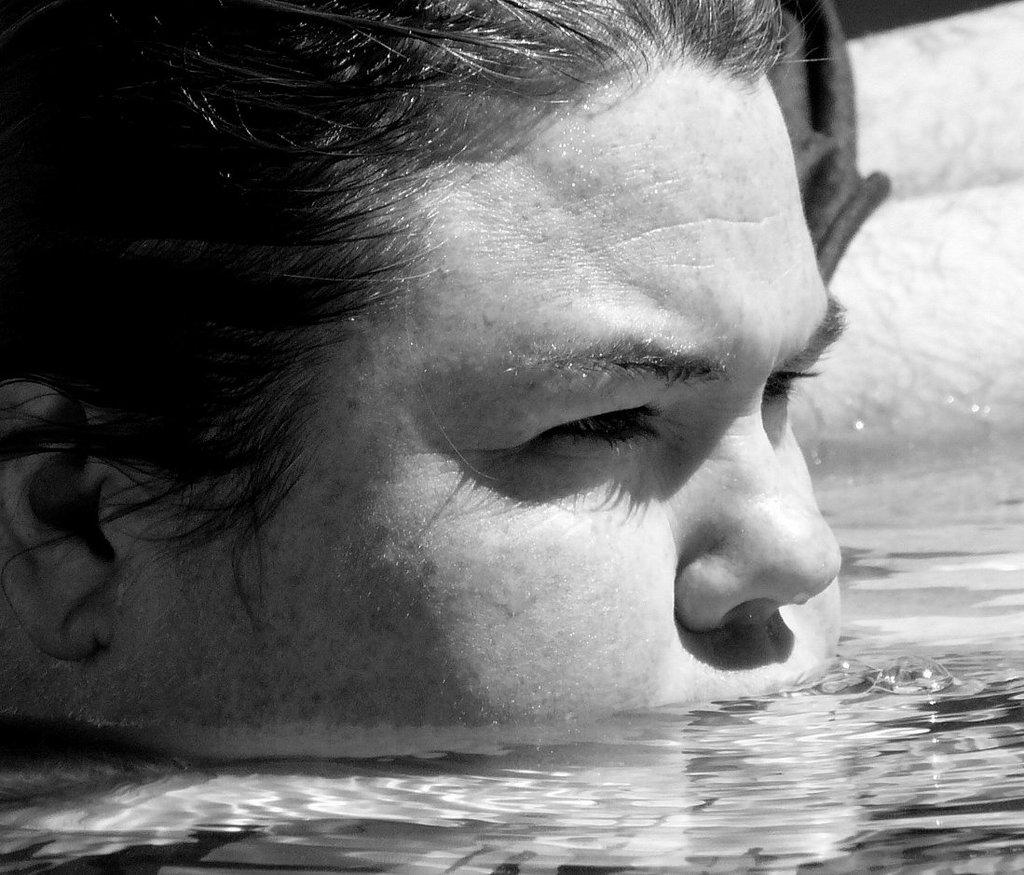What is the primary element present in the image? There is water in the image. What other object or feature can be seen in the image? There is a human face in the image. What can be observed in the background of the image? There is a white color wall in the background of the image. How many cars are parked next to the person in the image? There is no person or car present in the image. 